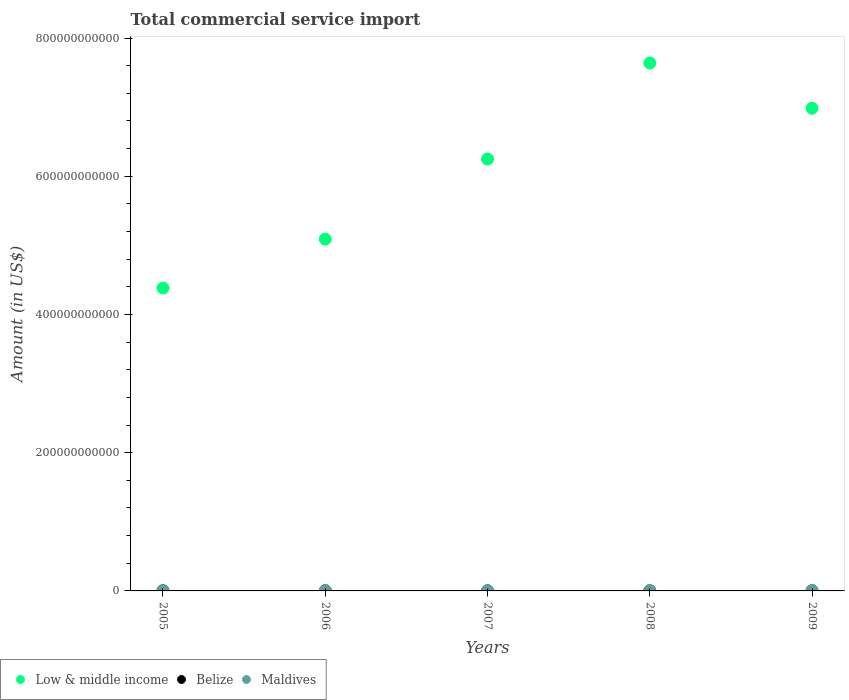Is the number of dotlines equal to the number of legend labels?
Keep it short and to the point. Yes. What is the total commercial service import in Belize in 2006?
Your answer should be compact. 1.43e+08. Across all years, what is the maximum total commercial service import in Low & middle income?
Your answer should be very brief. 7.64e+11. Across all years, what is the minimum total commercial service import in Maldives?
Your answer should be compact. 2.10e+08. What is the total total commercial service import in Belize in the graph?
Offer a terse response. 7.64e+08. What is the difference between the total commercial service import in Low & middle income in 2007 and that in 2008?
Offer a terse response. -1.39e+11. What is the difference between the total commercial service import in Maldives in 2008 and the total commercial service import in Low & middle income in 2007?
Offer a very short reply. -6.25e+11. What is the average total commercial service import in Belize per year?
Offer a terse response. 1.53e+08. In the year 2006, what is the difference between the total commercial service import in Low & middle income and total commercial service import in Belize?
Provide a short and direct response. 5.09e+11. What is the ratio of the total commercial service import in Low & middle income in 2005 to that in 2006?
Give a very brief answer. 0.86. What is the difference between the highest and the second highest total commercial service import in Low & middle income?
Make the answer very short. 6.55e+1. What is the difference between the highest and the lowest total commercial service import in Maldives?
Provide a short and direct response. 2.09e+08. Is the sum of the total commercial service import in Maldives in 2008 and 2009 greater than the maximum total commercial service import in Low & middle income across all years?
Keep it short and to the point. No. Does the total commercial service import in Belize monotonically increase over the years?
Make the answer very short. No. How many dotlines are there?
Keep it short and to the point. 3. What is the difference between two consecutive major ticks on the Y-axis?
Give a very brief answer. 2.00e+11. Does the graph contain any zero values?
Offer a terse response. No. How many legend labels are there?
Your answer should be compact. 3. How are the legend labels stacked?
Provide a short and direct response. Horizontal. What is the title of the graph?
Your response must be concise. Total commercial service import. Does "Dominica" appear as one of the legend labels in the graph?
Provide a short and direct response. No. What is the label or title of the X-axis?
Make the answer very short. Years. What is the Amount (in US$) of Low & middle income in 2005?
Provide a succinct answer. 4.38e+11. What is the Amount (in US$) of Belize in 2005?
Your response must be concise. 1.47e+08. What is the Amount (in US$) in Maldives in 2005?
Ensure brevity in your answer.  2.10e+08. What is the Amount (in US$) in Low & middle income in 2006?
Keep it short and to the point. 5.09e+11. What is the Amount (in US$) of Belize in 2006?
Your answer should be compact. 1.43e+08. What is the Amount (in US$) of Maldives in 2006?
Keep it short and to the point. 2.26e+08. What is the Amount (in US$) in Low & middle income in 2007?
Keep it short and to the point. 6.25e+11. What is the Amount (in US$) of Belize in 2007?
Provide a succinct answer. 1.59e+08. What is the Amount (in US$) in Maldives in 2007?
Provide a short and direct response. 3.26e+08. What is the Amount (in US$) of Low & middle income in 2008?
Your answer should be compact. 7.64e+11. What is the Amount (in US$) in Belize in 2008?
Ensure brevity in your answer.  1.61e+08. What is the Amount (in US$) of Maldives in 2008?
Keep it short and to the point. 4.19e+08. What is the Amount (in US$) in Low & middle income in 2009?
Your answer should be very brief. 6.98e+11. What is the Amount (in US$) in Belize in 2009?
Offer a terse response. 1.54e+08. What is the Amount (in US$) in Maldives in 2009?
Give a very brief answer. 3.94e+08. Across all years, what is the maximum Amount (in US$) in Low & middle income?
Keep it short and to the point. 7.64e+11. Across all years, what is the maximum Amount (in US$) in Belize?
Give a very brief answer. 1.61e+08. Across all years, what is the maximum Amount (in US$) in Maldives?
Offer a very short reply. 4.19e+08. Across all years, what is the minimum Amount (in US$) in Low & middle income?
Your answer should be very brief. 4.38e+11. Across all years, what is the minimum Amount (in US$) in Belize?
Your response must be concise. 1.43e+08. Across all years, what is the minimum Amount (in US$) of Maldives?
Provide a short and direct response. 2.10e+08. What is the total Amount (in US$) in Low & middle income in the graph?
Provide a succinct answer. 3.03e+12. What is the total Amount (in US$) of Belize in the graph?
Offer a terse response. 7.64e+08. What is the total Amount (in US$) of Maldives in the graph?
Keep it short and to the point. 1.58e+09. What is the difference between the Amount (in US$) of Low & middle income in 2005 and that in 2006?
Provide a succinct answer. -7.08e+1. What is the difference between the Amount (in US$) of Belize in 2005 and that in 2006?
Give a very brief answer. 3.89e+06. What is the difference between the Amount (in US$) in Maldives in 2005 and that in 2006?
Provide a short and direct response. -1.62e+07. What is the difference between the Amount (in US$) of Low & middle income in 2005 and that in 2007?
Your answer should be very brief. -1.87e+11. What is the difference between the Amount (in US$) of Belize in 2005 and that in 2007?
Your response must be concise. -1.18e+07. What is the difference between the Amount (in US$) in Maldives in 2005 and that in 2007?
Keep it short and to the point. -1.16e+08. What is the difference between the Amount (in US$) in Low & middle income in 2005 and that in 2008?
Offer a very short reply. -3.26e+11. What is the difference between the Amount (in US$) of Belize in 2005 and that in 2008?
Provide a short and direct response. -1.37e+07. What is the difference between the Amount (in US$) in Maldives in 2005 and that in 2008?
Ensure brevity in your answer.  -2.09e+08. What is the difference between the Amount (in US$) in Low & middle income in 2005 and that in 2009?
Provide a short and direct response. -2.60e+11. What is the difference between the Amount (in US$) in Belize in 2005 and that in 2009?
Ensure brevity in your answer.  -6.35e+06. What is the difference between the Amount (in US$) of Maldives in 2005 and that in 2009?
Offer a very short reply. -1.84e+08. What is the difference between the Amount (in US$) in Low & middle income in 2006 and that in 2007?
Make the answer very short. -1.16e+11. What is the difference between the Amount (in US$) in Belize in 2006 and that in 2007?
Give a very brief answer. -1.57e+07. What is the difference between the Amount (in US$) in Maldives in 2006 and that in 2007?
Ensure brevity in your answer.  -1.00e+08. What is the difference between the Amount (in US$) in Low & middle income in 2006 and that in 2008?
Offer a very short reply. -2.55e+11. What is the difference between the Amount (in US$) of Belize in 2006 and that in 2008?
Offer a terse response. -1.76e+07. What is the difference between the Amount (in US$) of Maldives in 2006 and that in 2008?
Ensure brevity in your answer.  -1.93e+08. What is the difference between the Amount (in US$) in Low & middle income in 2006 and that in 2009?
Offer a very short reply. -1.89e+11. What is the difference between the Amount (in US$) in Belize in 2006 and that in 2009?
Offer a terse response. -1.02e+07. What is the difference between the Amount (in US$) in Maldives in 2006 and that in 2009?
Your response must be concise. -1.68e+08. What is the difference between the Amount (in US$) of Low & middle income in 2007 and that in 2008?
Give a very brief answer. -1.39e+11. What is the difference between the Amount (in US$) of Belize in 2007 and that in 2008?
Provide a short and direct response. -1.87e+06. What is the difference between the Amount (in US$) of Maldives in 2007 and that in 2008?
Your answer should be compact. -9.31e+07. What is the difference between the Amount (in US$) in Low & middle income in 2007 and that in 2009?
Give a very brief answer. -7.35e+1. What is the difference between the Amount (in US$) in Belize in 2007 and that in 2009?
Provide a short and direct response. 5.46e+06. What is the difference between the Amount (in US$) in Maldives in 2007 and that in 2009?
Keep it short and to the point. -6.78e+07. What is the difference between the Amount (in US$) of Low & middle income in 2008 and that in 2009?
Ensure brevity in your answer.  6.55e+1. What is the difference between the Amount (in US$) of Belize in 2008 and that in 2009?
Offer a terse response. 7.33e+06. What is the difference between the Amount (in US$) of Maldives in 2008 and that in 2009?
Ensure brevity in your answer.  2.53e+07. What is the difference between the Amount (in US$) of Low & middle income in 2005 and the Amount (in US$) of Belize in 2006?
Offer a very short reply. 4.38e+11. What is the difference between the Amount (in US$) in Low & middle income in 2005 and the Amount (in US$) in Maldives in 2006?
Provide a short and direct response. 4.38e+11. What is the difference between the Amount (in US$) of Belize in 2005 and the Amount (in US$) of Maldives in 2006?
Keep it short and to the point. -7.92e+07. What is the difference between the Amount (in US$) of Low & middle income in 2005 and the Amount (in US$) of Belize in 2007?
Offer a terse response. 4.38e+11. What is the difference between the Amount (in US$) in Low & middle income in 2005 and the Amount (in US$) in Maldives in 2007?
Offer a very short reply. 4.38e+11. What is the difference between the Amount (in US$) in Belize in 2005 and the Amount (in US$) in Maldives in 2007?
Give a very brief answer. -1.79e+08. What is the difference between the Amount (in US$) of Low & middle income in 2005 and the Amount (in US$) of Belize in 2008?
Your response must be concise. 4.38e+11. What is the difference between the Amount (in US$) in Low & middle income in 2005 and the Amount (in US$) in Maldives in 2008?
Your response must be concise. 4.38e+11. What is the difference between the Amount (in US$) in Belize in 2005 and the Amount (in US$) in Maldives in 2008?
Ensure brevity in your answer.  -2.72e+08. What is the difference between the Amount (in US$) in Low & middle income in 2005 and the Amount (in US$) in Belize in 2009?
Offer a terse response. 4.38e+11. What is the difference between the Amount (in US$) of Low & middle income in 2005 and the Amount (in US$) of Maldives in 2009?
Your answer should be compact. 4.38e+11. What is the difference between the Amount (in US$) of Belize in 2005 and the Amount (in US$) of Maldives in 2009?
Your answer should be compact. -2.47e+08. What is the difference between the Amount (in US$) of Low & middle income in 2006 and the Amount (in US$) of Belize in 2007?
Give a very brief answer. 5.09e+11. What is the difference between the Amount (in US$) of Low & middle income in 2006 and the Amount (in US$) of Maldives in 2007?
Provide a short and direct response. 5.09e+11. What is the difference between the Amount (in US$) of Belize in 2006 and the Amount (in US$) of Maldives in 2007?
Give a very brief answer. -1.83e+08. What is the difference between the Amount (in US$) of Low & middle income in 2006 and the Amount (in US$) of Belize in 2008?
Ensure brevity in your answer.  5.09e+11. What is the difference between the Amount (in US$) of Low & middle income in 2006 and the Amount (in US$) of Maldives in 2008?
Offer a very short reply. 5.09e+11. What is the difference between the Amount (in US$) of Belize in 2006 and the Amount (in US$) of Maldives in 2008?
Give a very brief answer. -2.76e+08. What is the difference between the Amount (in US$) of Low & middle income in 2006 and the Amount (in US$) of Belize in 2009?
Your answer should be compact. 5.09e+11. What is the difference between the Amount (in US$) in Low & middle income in 2006 and the Amount (in US$) in Maldives in 2009?
Your answer should be very brief. 5.09e+11. What is the difference between the Amount (in US$) of Belize in 2006 and the Amount (in US$) of Maldives in 2009?
Your answer should be compact. -2.51e+08. What is the difference between the Amount (in US$) of Low & middle income in 2007 and the Amount (in US$) of Belize in 2008?
Keep it short and to the point. 6.25e+11. What is the difference between the Amount (in US$) in Low & middle income in 2007 and the Amount (in US$) in Maldives in 2008?
Ensure brevity in your answer.  6.25e+11. What is the difference between the Amount (in US$) of Belize in 2007 and the Amount (in US$) of Maldives in 2008?
Keep it short and to the point. -2.60e+08. What is the difference between the Amount (in US$) in Low & middle income in 2007 and the Amount (in US$) in Belize in 2009?
Your answer should be very brief. 6.25e+11. What is the difference between the Amount (in US$) in Low & middle income in 2007 and the Amount (in US$) in Maldives in 2009?
Keep it short and to the point. 6.25e+11. What is the difference between the Amount (in US$) in Belize in 2007 and the Amount (in US$) in Maldives in 2009?
Offer a very short reply. -2.35e+08. What is the difference between the Amount (in US$) in Low & middle income in 2008 and the Amount (in US$) in Belize in 2009?
Offer a very short reply. 7.64e+11. What is the difference between the Amount (in US$) in Low & middle income in 2008 and the Amount (in US$) in Maldives in 2009?
Provide a succinct answer. 7.64e+11. What is the difference between the Amount (in US$) in Belize in 2008 and the Amount (in US$) in Maldives in 2009?
Ensure brevity in your answer.  -2.33e+08. What is the average Amount (in US$) in Low & middle income per year?
Make the answer very short. 6.07e+11. What is the average Amount (in US$) of Belize per year?
Ensure brevity in your answer.  1.53e+08. What is the average Amount (in US$) in Maldives per year?
Offer a very short reply. 3.15e+08. In the year 2005, what is the difference between the Amount (in US$) of Low & middle income and Amount (in US$) of Belize?
Provide a short and direct response. 4.38e+11. In the year 2005, what is the difference between the Amount (in US$) of Low & middle income and Amount (in US$) of Maldives?
Provide a short and direct response. 4.38e+11. In the year 2005, what is the difference between the Amount (in US$) in Belize and Amount (in US$) in Maldives?
Your response must be concise. -6.30e+07. In the year 2006, what is the difference between the Amount (in US$) in Low & middle income and Amount (in US$) in Belize?
Give a very brief answer. 5.09e+11. In the year 2006, what is the difference between the Amount (in US$) of Low & middle income and Amount (in US$) of Maldives?
Keep it short and to the point. 5.09e+11. In the year 2006, what is the difference between the Amount (in US$) in Belize and Amount (in US$) in Maldives?
Offer a very short reply. -8.31e+07. In the year 2007, what is the difference between the Amount (in US$) of Low & middle income and Amount (in US$) of Belize?
Provide a short and direct response. 6.25e+11. In the year 2007, what is the difference between the Amount (in US$) in Low & middle income and Amount (in US$) in Maldives?
Provide a short and direct response. 6.25e+11. In the year 2007, what is the difference between the Amount (in US$) in Belize and Amount (in US$) in Maldives?
Your answer should be compact. -1.67e+08. In the year 2008, what is the difference between the Amount (in US$) of Low & middle income and Amount (in US$) of Belize?
Make the answer very short. 7.64e+11. In the year 2008, what is the difference between the Amount (in US$) in Low & middle income and Amount (in US$) in Maldives?
Provide a short and direct response. 7.64e+11. In the year 2008, what is the difference between the Amount (in US$) of Belize and Amount (in US$) of Maldives?
Offer a terse response. -2.59e+08. In the year 2009, what is the difference between the Amount (in US$) of Low & middle income and Amount (in US$) of Belize?
Offer a terse response. 6.98e+11. In the year 2009, what is the difference between the Amount (in US$) in Low & middle income and Amount (in US$) in Maldives?
Provide a short and direct response. 6.98e+11. In the year 2009, what is the difference between the Amount (in US$) of Belize and Amount (in US$) of Maldives?
Offer a terse response. -2.41e+08. What is the ratio of the Amount (in US$) of Low & middle income in 2005 to that in 2006?
Ensure brevity in your answer.  0.86. What is the ratio of the Amount (in US$) of Belize in 2005 to that in 2006?
Give a very brief answer. 1.03. What is the ratio of the Amount (in US$) of Maldives in 2005 to that in 2006?
Ensure brevity in your answer.  0.93. What is the ratio of the Amount (in US$) in Low & middle income in 2005 to that in 2007?
Offer a very short reply. 0.7. What is the ratio of the Amount (in US$) in Belize in 2005 to that in 2007?
Offer a very short reply. 0.93. What is the ratio of the Amount (in US$) in Maldives in 2005 to that in 2007?
Make the answer very short. 0.64. What is the ratio of the Amount (in US$) of Low & middle income in 2005 to that in 2008?
Provide a succinct answer. 0.57. What is the ratio of the Amount (in US$) in Belize in 2005 to that in 2008?
Your response must be concise. 0.92. What is the ratio of the Amount (in US$) in Maldives in 2005 to that in 2008?
Offer a very short reply. 0.5. What is the ratio of the Amount (in US$) of Low & middle income in 2005 to that in 2009?
Offer a very short reply. 0.63. What is the ratio of the Amount (in US$) in Belize in 2005 to that in 2009?
Provide a short and direct response. 0.96. What is the ratio of the Amount (in US$) of Maldives in 2005 to that in 2009?
Your answer should be compact. 0.53. What is the ratio of the Amount (in US$) in Low & middle income in 2006 to that in 2007?
Keep it short and to the point. 0.81. What is the ratio of the Amount (in US$) of Belize in 2006 to that in 2007?
Your answer should be very brief. 0.9. What is the ratio of the Amount (in US$) of Maldives in 2006 to that in 2007?
Provide a short and direct response. 0.69. What is the ratio of the Amount (in US$) in Low & middle income in 2006 to that in 2008?
Your response must be concise. 0.67. What is the ratio of the Amount (in US$) in Belize in 2006 to that in 2008?
Keep it short and to the point. 0.89. What is the ratio of the Amount (in US$) of Maldives in 2006 to that in 2008?
Offer a terse response. 0.54. What is the ratio of the Amount (in US$) of Low & middle income in 2006 to that in 2009?
Your response must be concise. 0.73. What is the ratio of the Amount (in US$) in Belize in 2006 to that in 2009?
Your answer should be very brief. 0.93. What is the ratio of the Amount (in US$) in Maldives in 2006 to that in 2009?
Provide a short and direct response. 0.57. What is the ratio of the Amount (in US$) of Low & middle income in 2007 to that in 2008?
Ensure brevity in your answer.  0.82. What is the ratio of the Amount (in US$) of Belize in 2007 to that in 2008?
Provide a short and direct response. 0.99. What is the ratio of the Amount (in US$) in Maldives in 2007 to that in 2008?
Ensure brevity in your answer.  0.78. What is the ratio of the Amount (in US$) in Low & middle income in 2007 to that in 2009?
Your answer should be very brief. 0.89. What is the ratio of the Amount (in US$) in Belize in 2007 to that in 2009?
Offer a terse response. 1.04. What is the ratio of the Amount (in US$) of Maldives in 2007 to that in 2009?
Provide a short and direct response. 0.83. What is the ratio of the Amount (in US$) in Low & middle income in 2008 to that in 2009?
Ensure brevity in your answer.  1.09. What is the ratio of the Amount (in US$) in Belize in 2008 to that in 2009?
Your answer should be very brief. 1.05. What is the ratio of the Amount (in US$) in Maldives in 2008 to that in 2009?
Provide a succinct answer. 1.06. What is the difference between the highest and the second highest Amount (in US$) in Low & middle income?
Ensure brevity in your answer.  6.55e+1. What is the difference between the highest and the second highest Amount (in US$) of Belize?
Offer a very short reply. 1.87e+06. What is the difference between the highest and the second highest Amount (in US$) of Maldives?
Keep it short and to the point. 2.53e+07. What is the difference between the highest and the lowest Amount (in US$) in Low & middle income?
Provide a short and direct response. 3.26e+11. What is the difference between the highest and the lowest Amount (in US$) in Belize?
Ensure brevity in your answer.  1.76e+07. What is the difference between the highest and the lowest Amount (in US$) in Maldives?
Your answer should be very brief. 2.09e+08. 